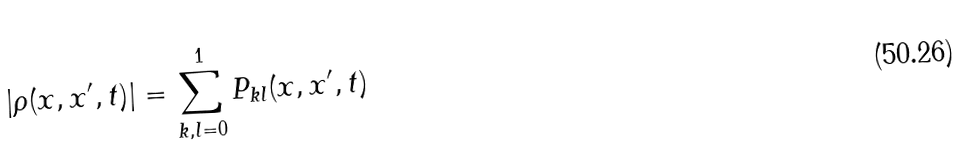<formula> <loc_0><loc_0><loc_500><loc_500>| \rho ( x , x ^ { \prime } , t ) | = \sum _ { k , l = 0 } ^ { 1 } P _ { k l } ( x , x ^ { \prime } , t )</formula> 